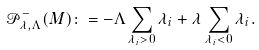Convert formula to latex. <formula><loc_0><loc_0><loc_500><loc_500>\mathcal { P } ^ { - } _ { \lambda , \Lambda } ( M ) \colon = - \Lambda \sum _ { \lambda _ { i } > 0 } \lambda _ { i } + \lambda \sum _ { \lambda _ { i } < 0 } \lambda _ { i } .</formula> 